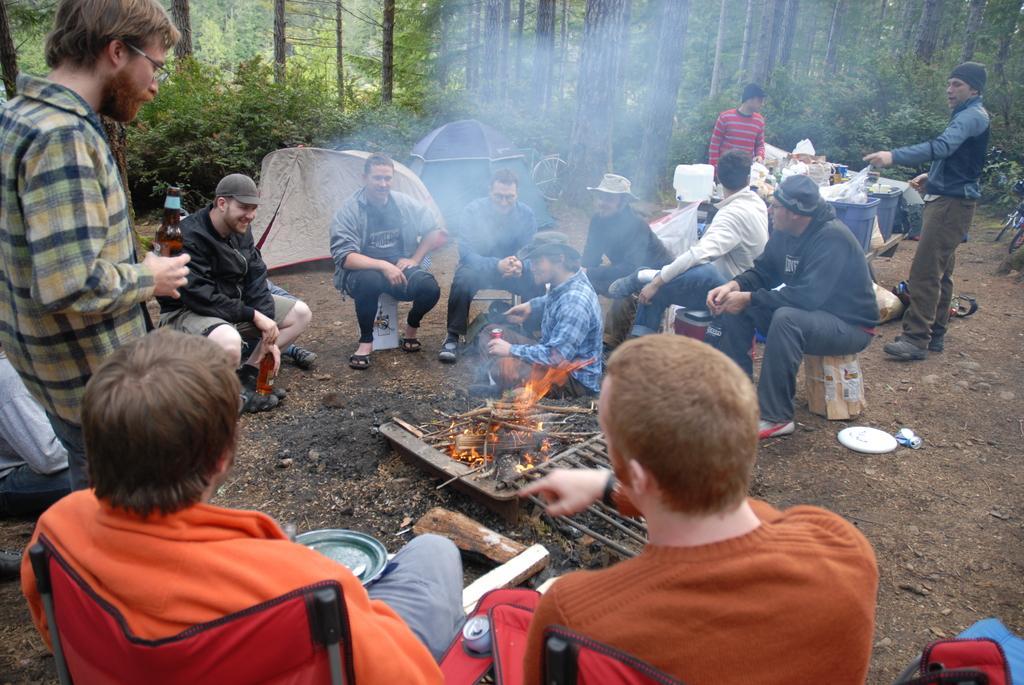In one or two sentences, can you explain what this image depicts? In this image we can see the persons sitting on the objects on the land. We can also see the wooden sticks, grill and also the fire. In the background, we can see many trees. We can also see the camping tents, a bicycle. There is also a man holding the alcohol bottle and standing on the left. In the background, we can see some bins with covers and some items. 